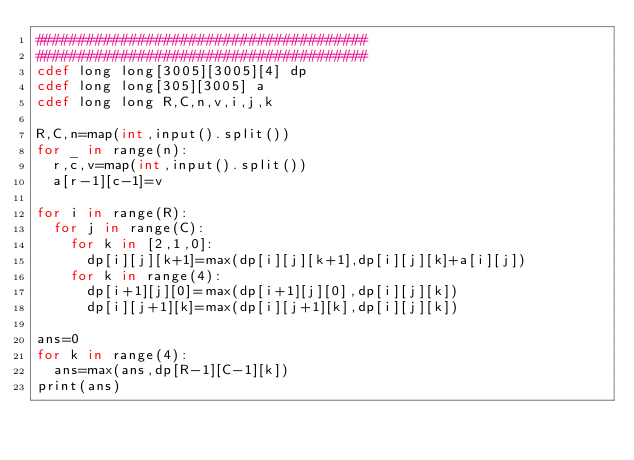<code> <loc_0><loc_0><loc_500><loc_500><_Cython_>#######################################
#######################################
cdef long long[3005][3005][4] dp
cdef long long[305][3005] a
cdef long long R,C,n,v,i,j,k

R,C,n=map(int,input().split())
for _ in range(n):
  r,c,v=map(int,input().split())
  a[r-1][c-1]=v

for i in range(R):
  for j in range(C):
    for k in [2,1,0]:
      dp[i][j][k+1]=max(dp[i][j][k+1],dp[i][j][k]+a[i][j])
    for k in range(4):
      dp[i+1][j][0]=max(dp[i+1][j][0],dp[i][j][k])
      dp[i][j+1][k]=max(dp[i][j+1][k],dp[i][j][k])
      
ans=0
for k in range(4):
  ans=max(ans,dp[R-1][C-1][k])
print(ans)
</code> 